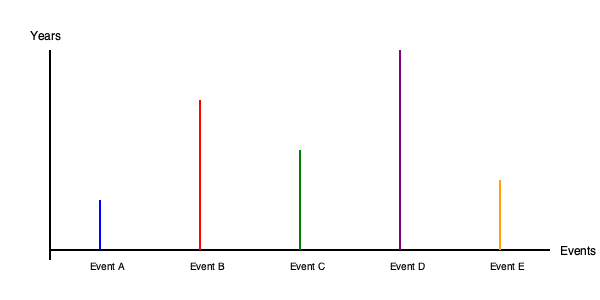In creating a timeline exhibition for local residents' historical events, you've represented each event with a vertical line. The length of each line corresponds to the event's duration or significance. Based on the timeline shown, which event appears to have the longest duration or greatest significance in the local history? To determine which event has the longest duration or greatest significance, we need to compare the lengths of the vertical lines representing each event:

1. Event A (blue): Relatively short line, indicating a brief or less significant event.
2. Event B (red): Longer line, suggesting more duration or significance than Event A.
3. Event C (green): Medium-length line, indicating moderate duration or significance.
4. Event D (purple): The longest line on the timeline, extending from the bottom to nearly the top of the graph.
5. Event E (orange): Slightly longer than Event A, but shorter than Events B, C, and D.

By comparing these line lengths, we can conclude that Event D, represented by the purple line, has the longest vertical line. In the context of creating a timeline exhibition, this suggests that Event D has either the longest duration or the greatest significance in the local history being showcased.
Answer: Event D 